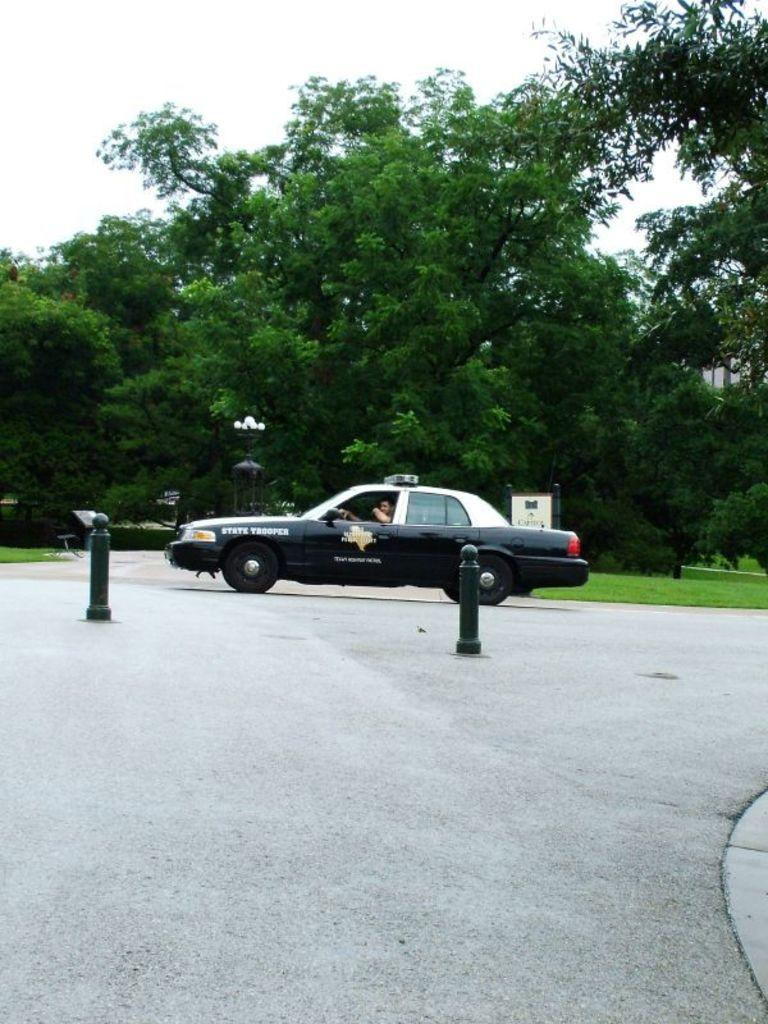What is the main subject of the image? The main subject of the image is a car. Who or what is inside the car? A man is inside the car. Where is the car located? The car is on a road. What objects are in front of the car? There are two traffic cones in front of the car. What can be seen behind the car? There are trees on the grass land behind the car. What is visible above the car? The sky is visible above the car. How many passengers are in the car, and what committee do they represent? There is no information about passengers or a committee in the image; it only shows a man inside the car. What type of ice is being used to cool the car's engine in the image? There is no ice present in the image, and the car's engine is not being cooled. 